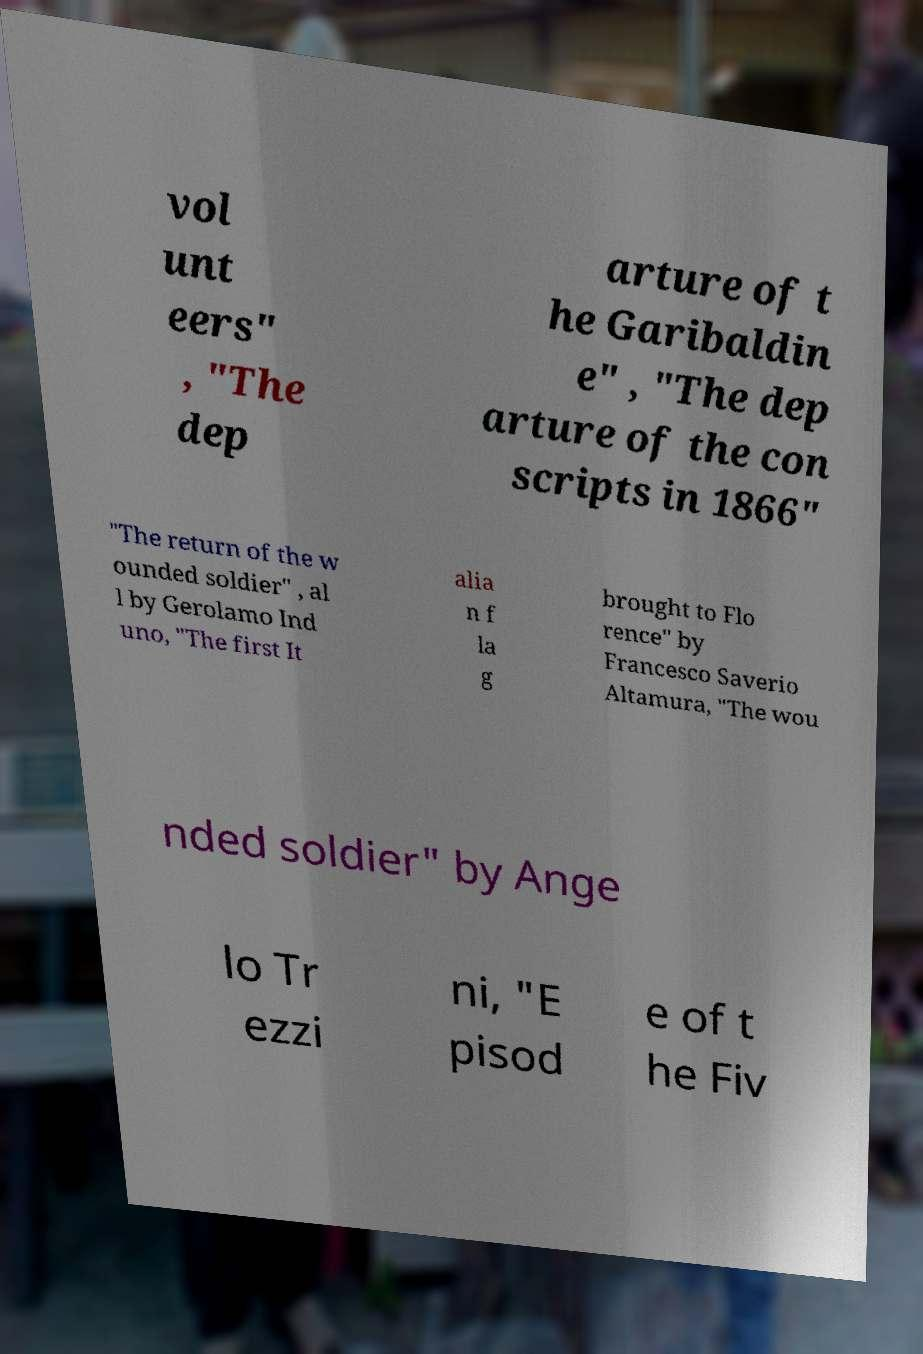Please read and relay the text visible in this image. What does it say? vol unt eers" , "The dep arture of t he Garibaldin e" , "The dep arture of the con scripts in 1866" "The return of the w ounded soldier" , al l by Gerolamo Ind uno, "The first It alia n f la g brought to Flo rence" by Francesco Saverio Altamura, "The wou nded soldier" by Ange lo Tr ezzi ni, "E pisod e of t he Fiv 